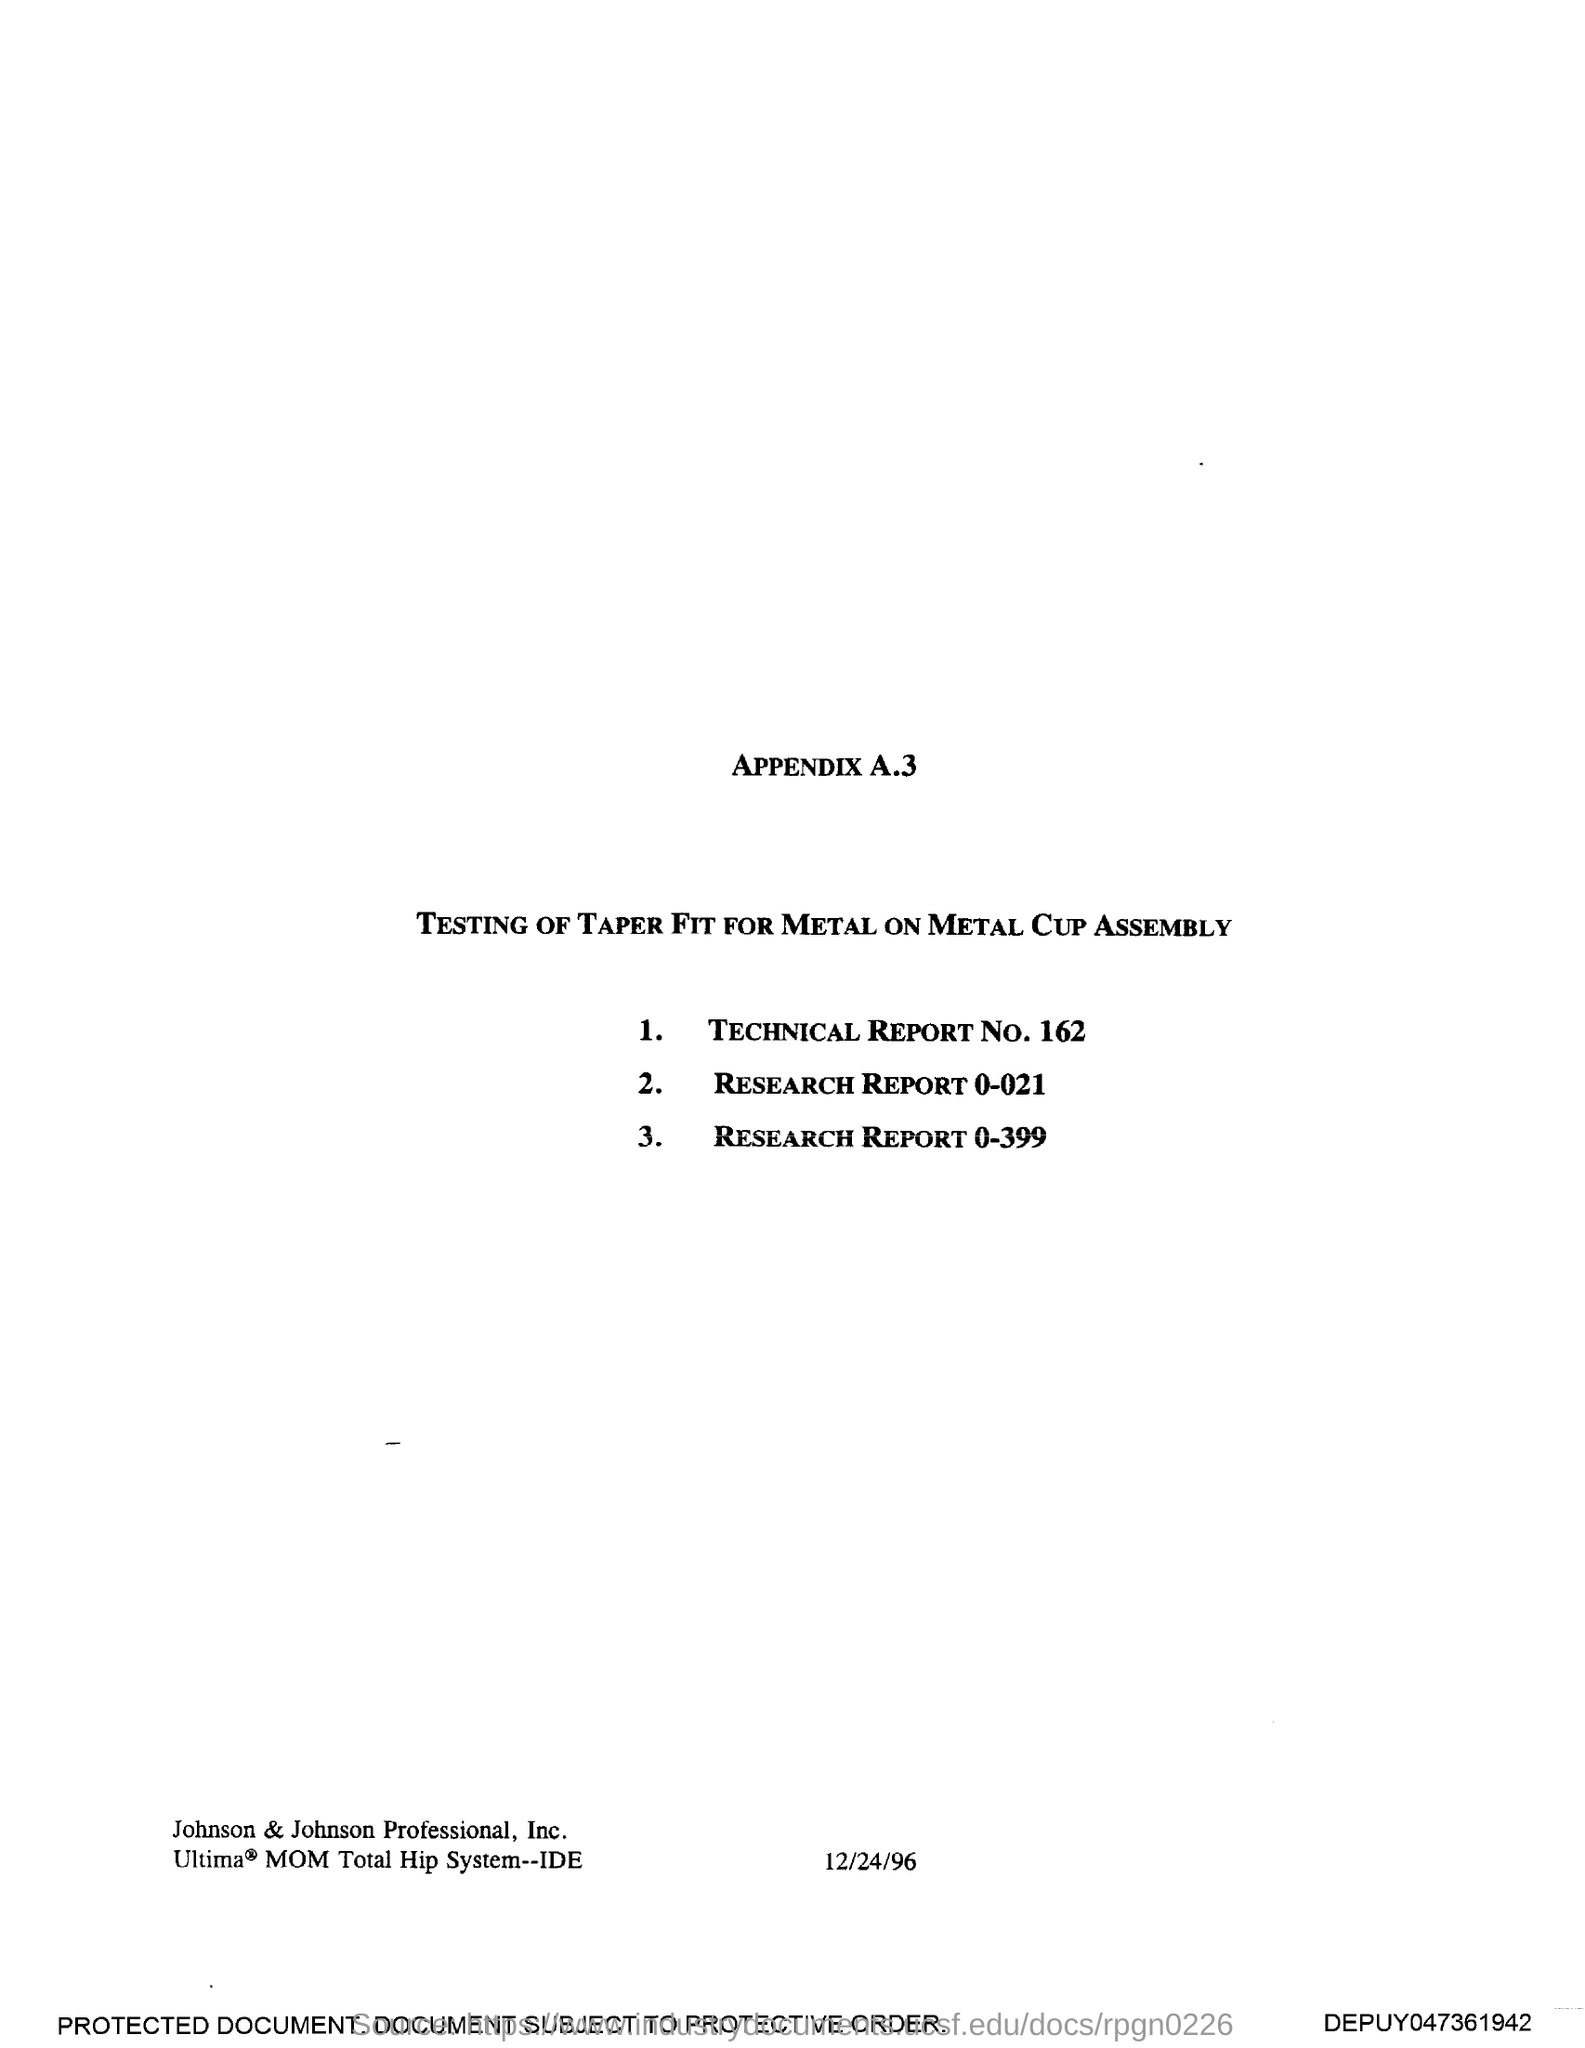What is the date mentioned in this document?
Offer a very short reply. 12/24/96. 